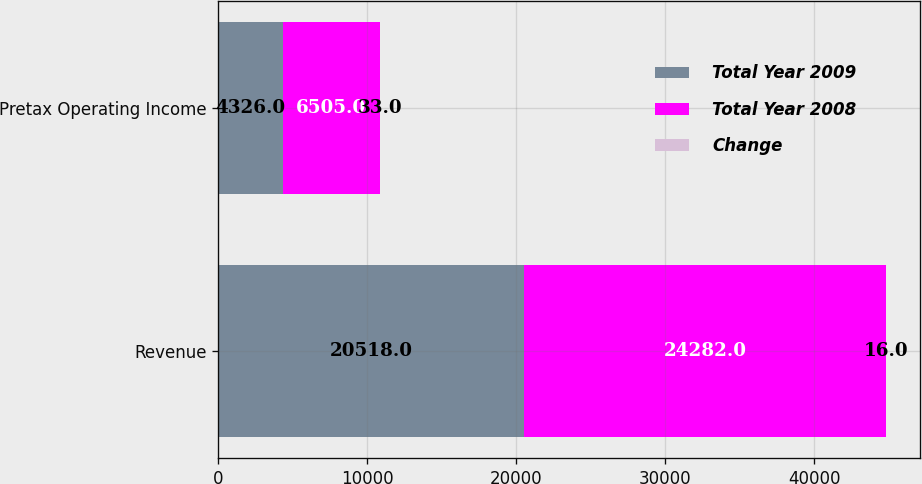Convert chart. <chart><loc_0><loc_0><loc_500><loc_500><stacked_bar_chart><ecel><fcel>Revenue<fcel>Pretax Operating Income<nl><fcel>Total Year 2009<fcel>20518<fcel>4326<nl><fcel>Total Year 2008<fcel>24282<fcel>6505<nl><fcel>Change<fcel>16<fcel>33<nl></chart> 